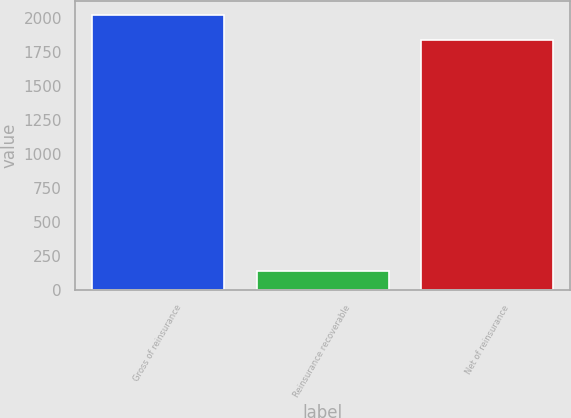Convert chart. <chart><loc_0><loc_0><loc_500><loc_500><bar_chart><fcel>Gross of reinsurance<fcel>Reinsurance recoverable<fcel>Net of reinsurance<nl><fcel>2024<fcel>138<fcel>1840<nl></chart> 